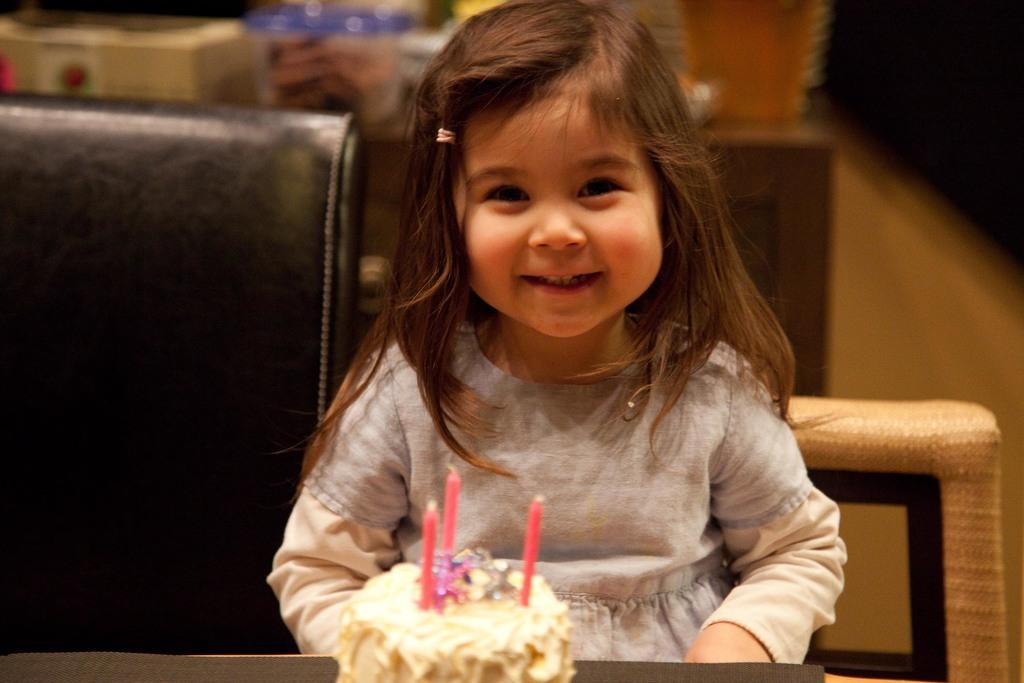What is the girl doing in the image? The girl is sitting on a chair in the image. Where is the girl located in relation to the table? The girl is at a table in the image. What is on the table in the image? There is a cake with candles on the table. Can you describe the background of the image? There are chairs and the floor visible in the background, along with other items. What type of industry can be seen in the background of the image? There is no industry present in the background of the image. Is there a basin visible in the image? There is no basin present in the image. 